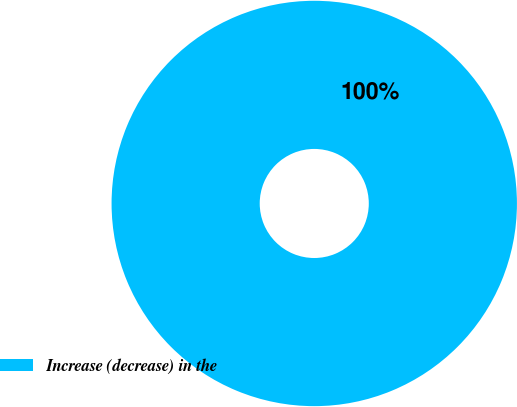<chart> <loc_0><loc_0><loc_500><loc_500><pie_chart><fcel>Increase (decrease) in the<nl><fcel>100.0%<nl></chart> 